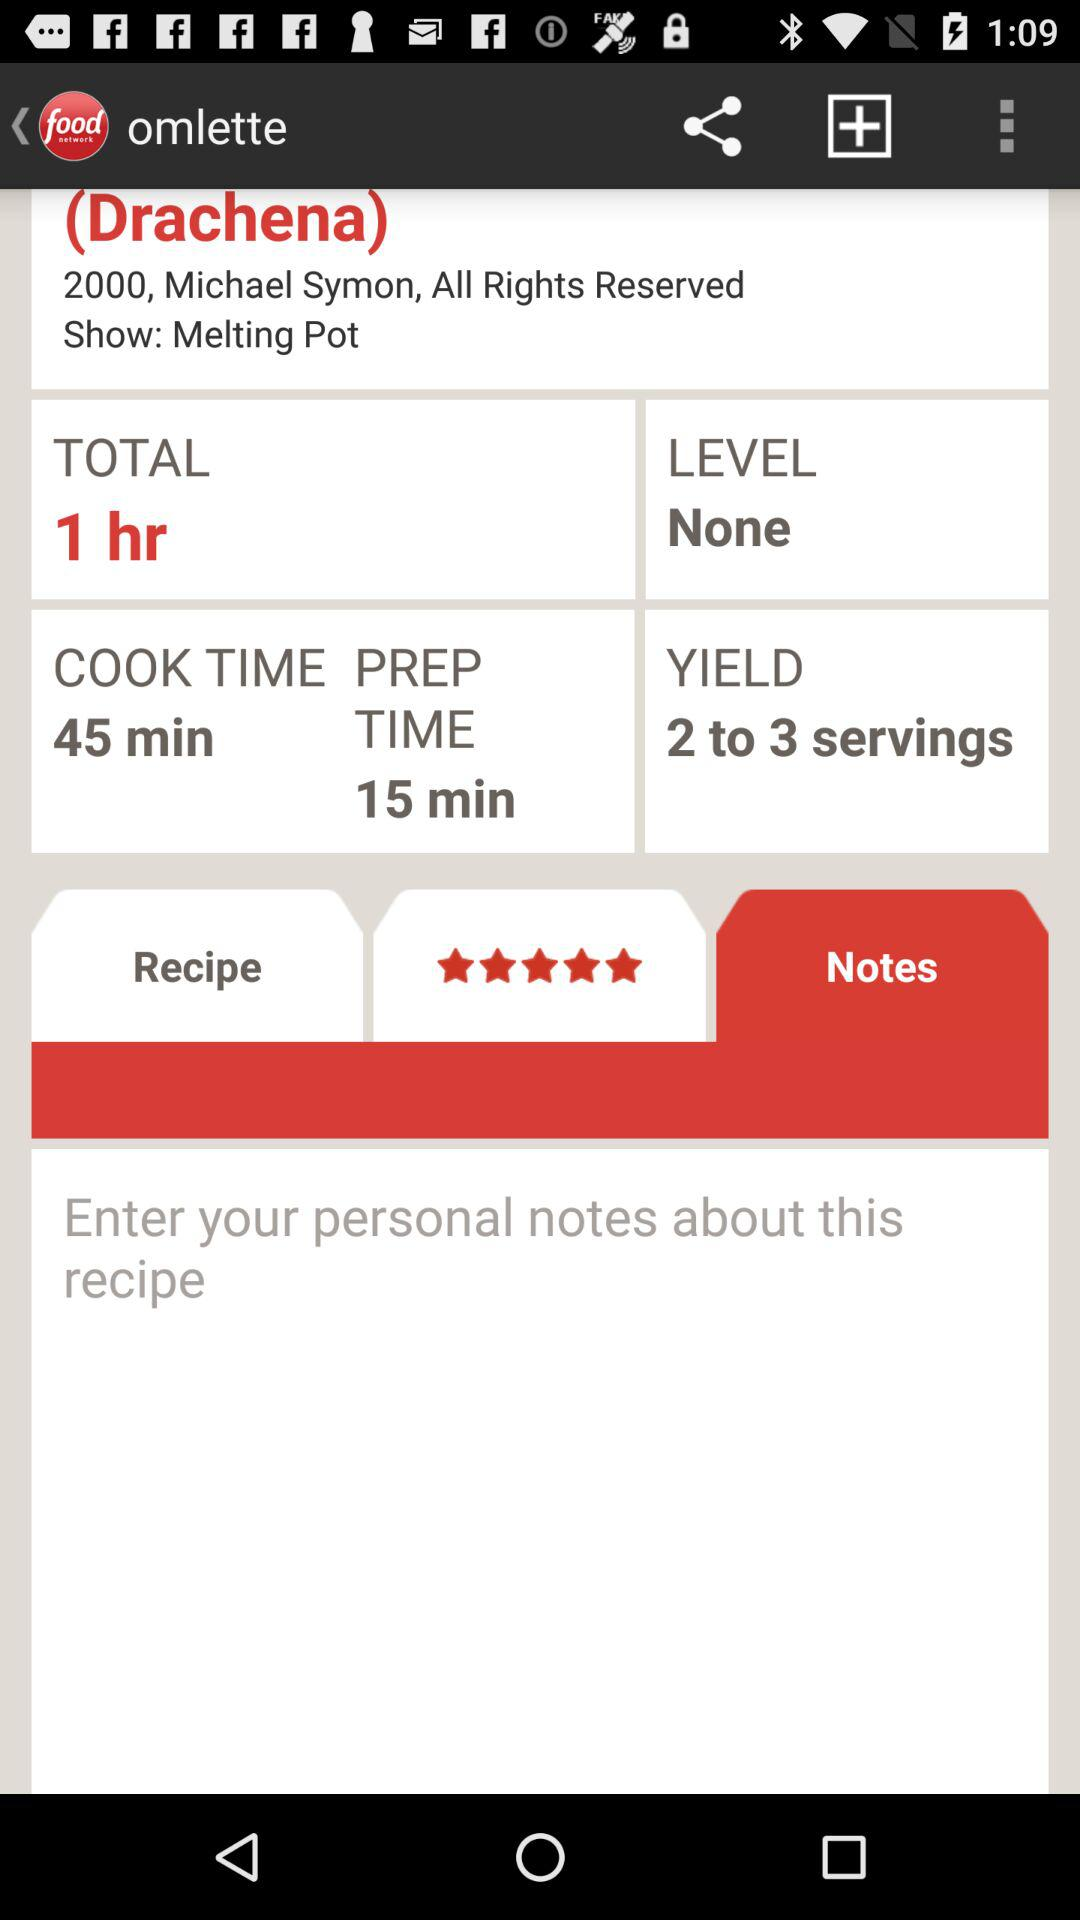What is the level? The level is "None". 